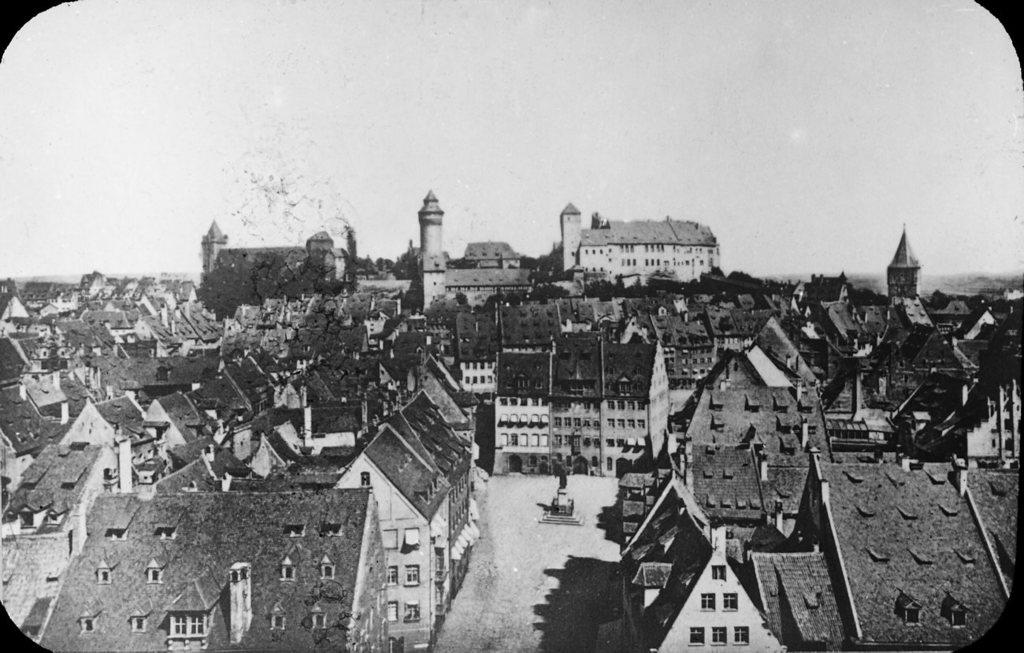What is the color scheme of the image? The image is black and white. What is the main subject in the image? There is a statue in the image. What else can be seen in the image besides the statue? There is a road, buildings, a castle, and the sky visible in the image. Can you see a patch of grass near the statue in the image? There is no patch of grass mentioned in the provided facts, and the image is black and white, so it's not possible to determine the presence of grass. 